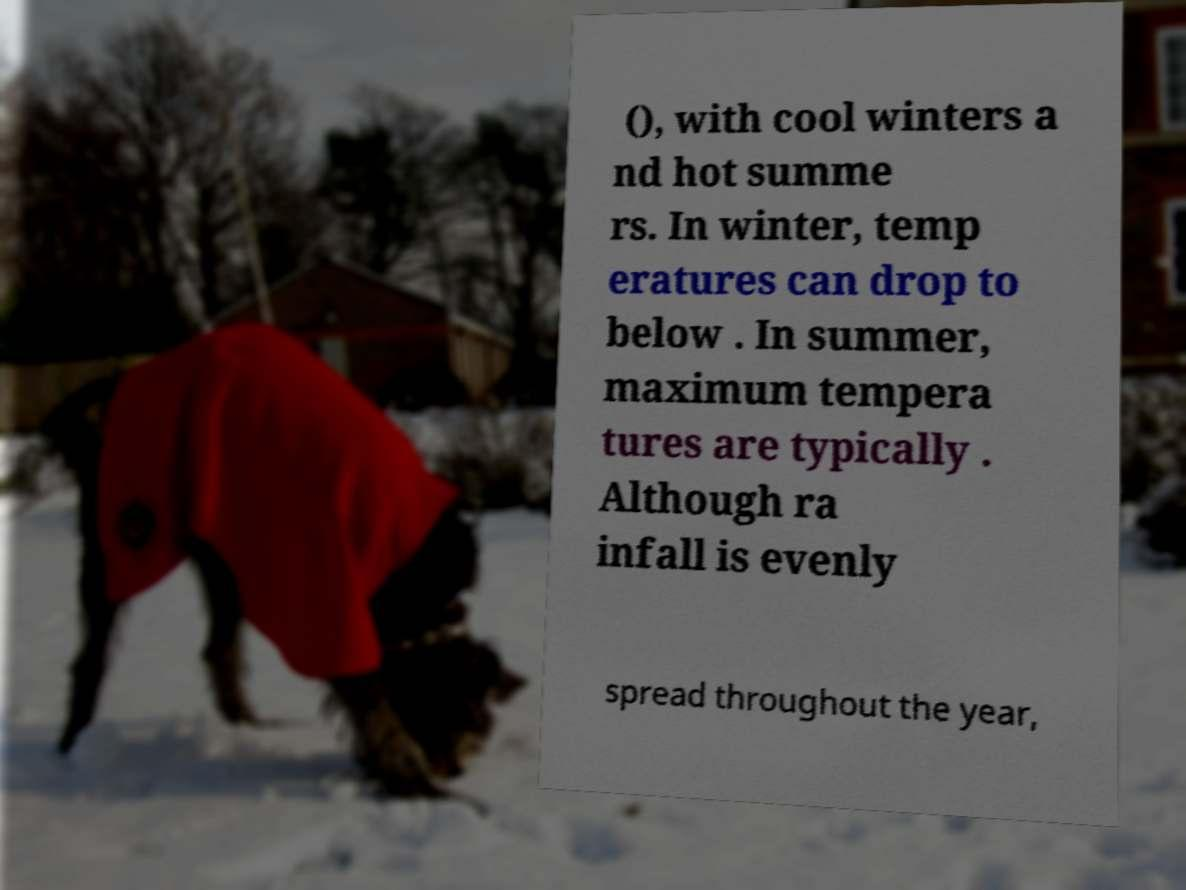Could you extract and type out the text from this image? (), with cool winters a nd hot summe rs. In winter, temp eratures can drop to below . In summer, maximum tempera tures are typically . Although ra infall is evenly spread throughout the year, 